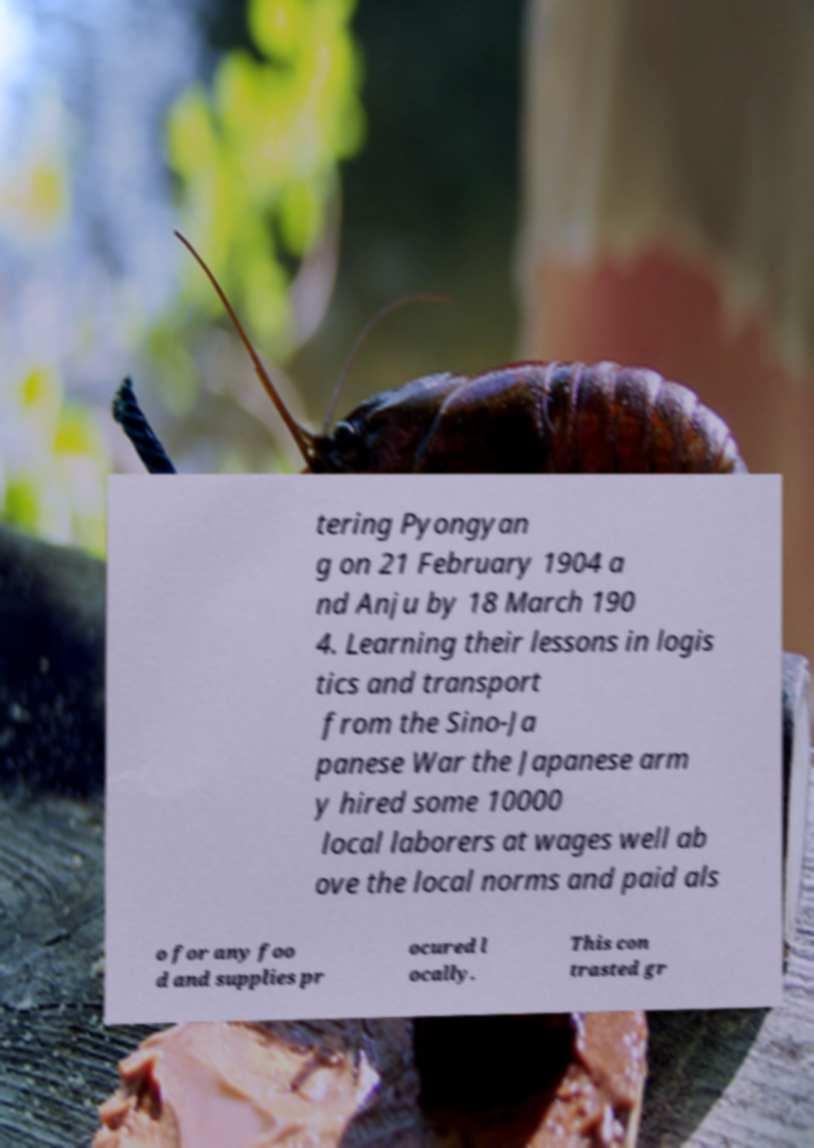There's text embedded in this image that I need extracted. Can you transcribe it verbatim? tering Pyongyan g on 21 February 1904 a nd Anju by 18 March 190 4. Learning their lessons in logis tics and transport from the Sino-Ja panese War the Japanese arm y hired some 10000 local laborers at wages well ab ove the local norms and paid als o for any foo d and supplies pr ocured l ocally. This con trasted gr 